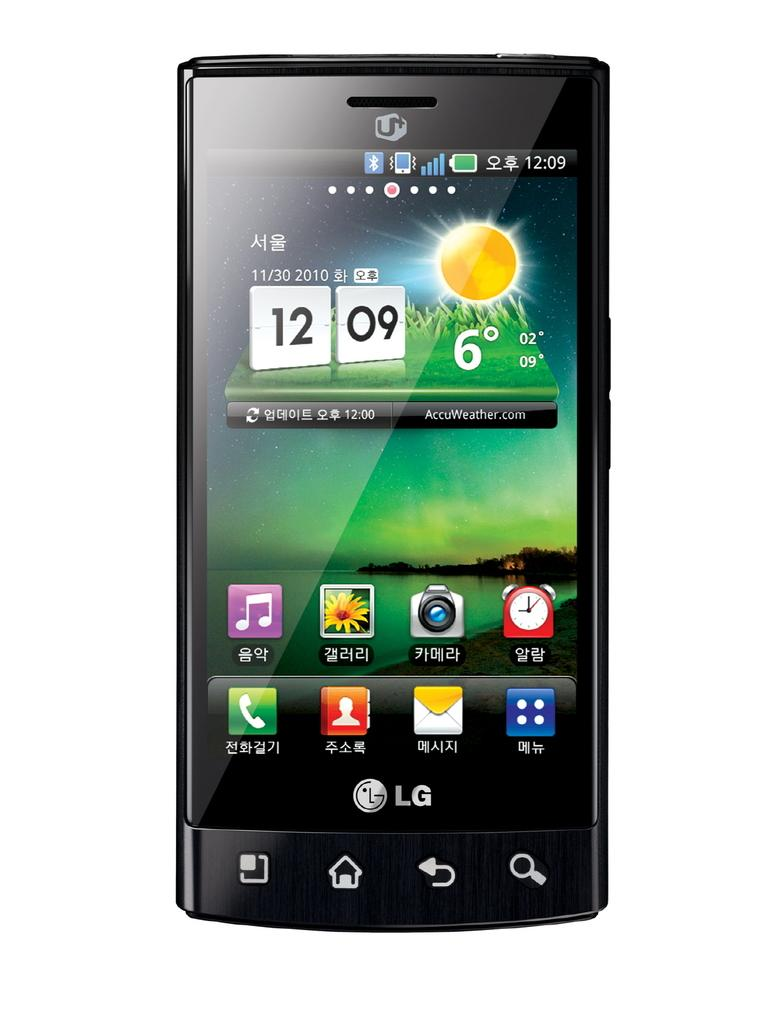<image>
Give a short and clear explanation of the subsequent image. The front of an LG branded cell phone that displays the weather beign 6 degrees on it. 